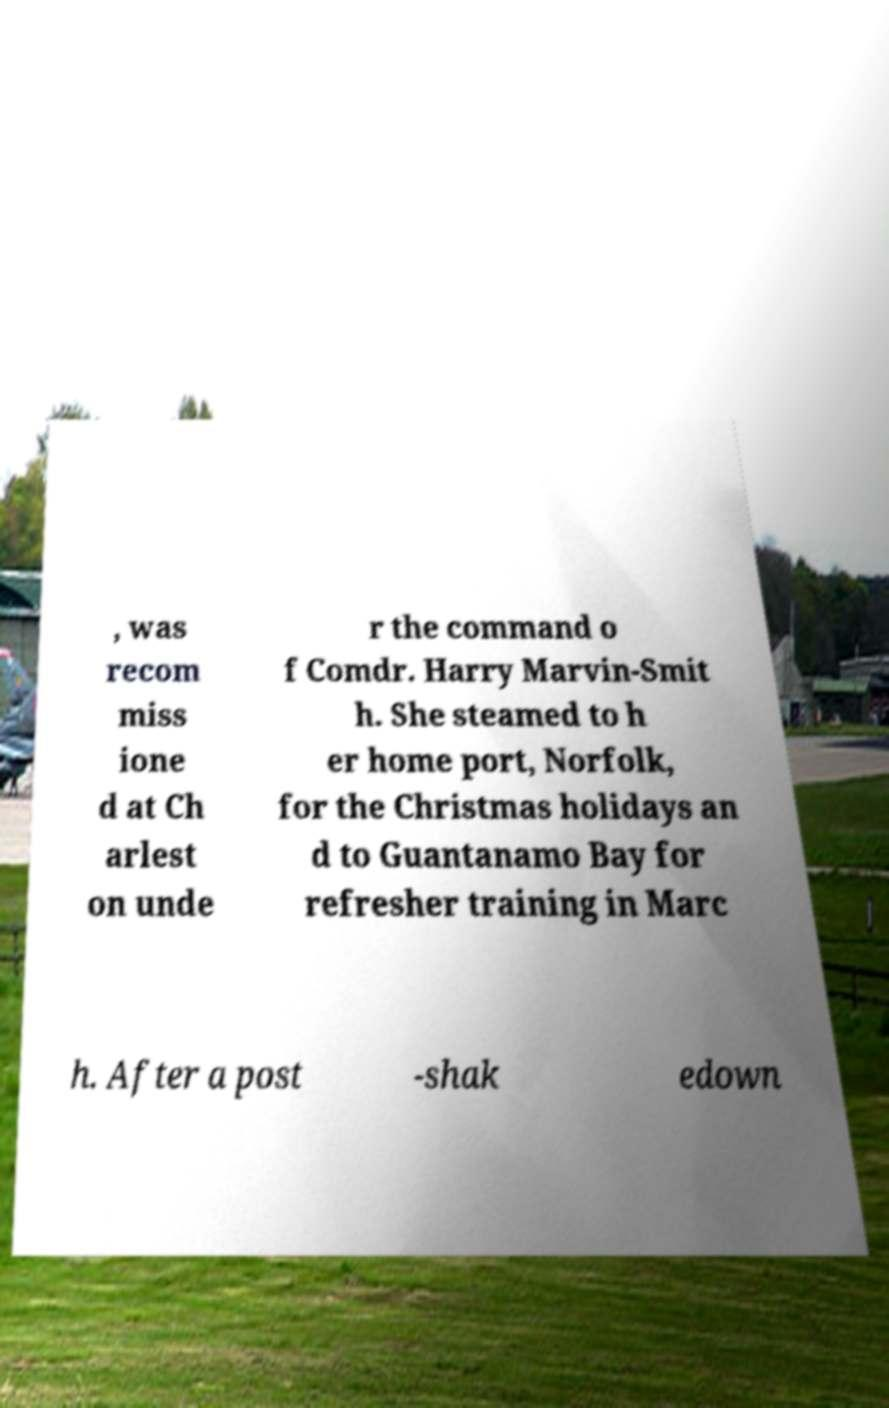What messages or text are displayed in this image? I need them in a readable, typed format. , was recom miss ione d at Ch arlest on unde r the command o f Comdr. Harry Marvin-Smit h. She steamed to h er home port, Norfolk, for the Christmas holidays an d to Guantanamo Bay for refresher training in Marc h. After a post -shak edown 